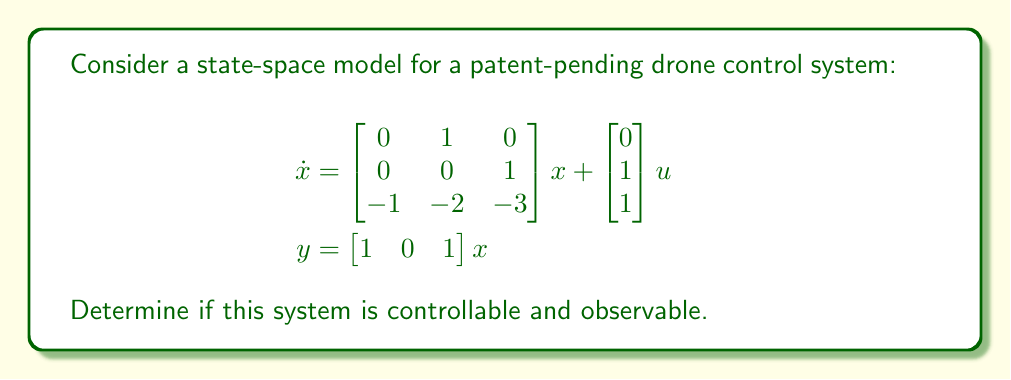Help me with this question. To evaluate the controllability and observability of this state-space model, we need to check the ranks of the controllability and observability matrices.

1. Controllability:
The controllability matrix is given by $C = [B \quad AB \quad A^2B]$, where $A$ is the state matrix and $B$ is the input matrix.

$B = \begin{bmatrix} 0 \\ 1 \\ 1 \end{bmatrix}$

$AB = \begin{bmatrix} 0 & 1 & 0 \\ 0 & 0 & 1 \\ -1 & -2 & -3 \end{bmatrix} \begin{bmatrix} 0 \\ 1 \\ 1 \end{bmatrix} = \begin{bmatrix} 1 \\ 1 \\ -5 \end{bmatrix}$

$A^2B = \begin{bmatrix} 0 & 1 & 0 \\ 0 & 0 & 1 \\ -1 & -2 & -3 \end{bmatrix} \begin{bmatrix} 1 \\ 1 \\ -5 \end{bmatrix} = \begin{bmatrix} 1 \\ -5 \\ -16 \end{bmatrix}$

Therefore, the controllability matrix is:

$C = \begin{bmatrix} 0 & 1 & 1 \\ 1 & 1 & -5 \\ 1 & -5 & -16 \end{bmatrix}$

The rank of $C$ is 3, which is equal to the number of states. Thus, the system is controllable.

2. Observability:
The observability matrix is given by $O = [C^T \quad (CA)^T \quad (CA^2)^T]^T$, where $C$ is the output matrix.

$C = \begin{bmatrix} 1 & 0 & 1 \end{bmatrix}$

$CA = \begin{bmatrix} 1 & 0 & 1 \end{bmatrix} \begin{bmatrix} 0 & 1 & 0 \\ 0 & 0 & 1 \\ -1 & -2 & -3 \end{bmatrix} = \begin{bmatrix} -1 & -1 & -3 \end{bmatrix}$

$CA^2 = \begin{bmatrix} -1 & -1 & -3 \end{bmatrix} \begin{bmatrix} 0 & 1 & 0 \\ 0 & 0 & 1 \\ -1 & -2 & -3 \end{bmatrix} = \begin{bmatrix} 3 & 5 & 8 \end{bmatrix}$

Therefore, the observability matrix is:

$O = \begin{bmatrix} 1 & 0 & 1 \\ -1 & -1 & -3 \\ 3 & 5 & 8 \end{bmatrix}$

The rank of $O$ is 3, which is equal to the number of states. Thus, the system is observable.
Answer: The system is both controllable and observable. 